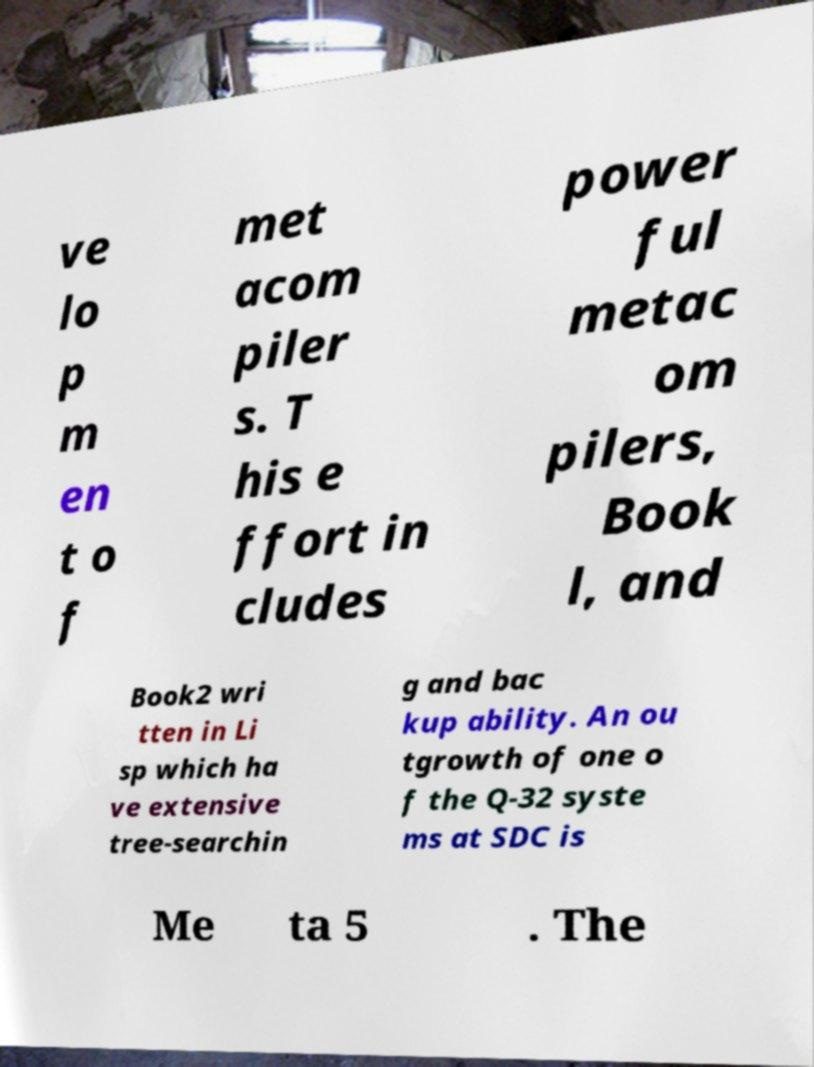I need the written content from this picture converted into text. Can you do that? ve lo p m en t o f met acom piler s. T his e ffort in cludes power ful metac om pilers, Book l, and Book2 wri tten in Li sp which ha ve extensive tree-searchin g and bac kup ability. An ou tgrowth of one o f the Q-32 syste ms at SDC is Me ta 5 . The 